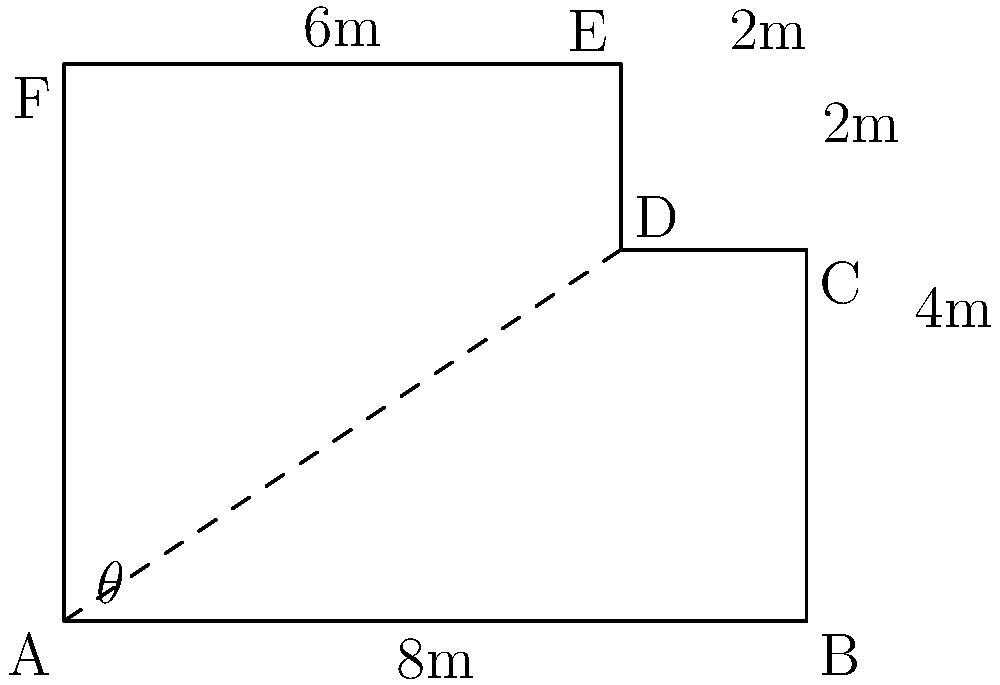An art gallery has an irregularly shaped floor plan as shown in the diagram. The gallery owner wants to calculate the total area to determine the cost of a new flooring installation. Given that angle $\theta = 33.69°$, calculate the total area of the art gallery floor in square meters. To find the total area, we'll divide the floor plan into rectangular and triangular sections:

1. Rectangle BCDE:
   Area = 8m × 4m = 32 m²

2. Rectangle ADEF:
   Area = 6m × 6m = 36 m²

3. Triangle ABD:
   We need to find the height (h) of this triangle.
   $\tan(\theta) = \frac{h}{8}$
   $h = 8 \tan(33.69°) = 5.33$ m
   Area = $\frac{1}{2} \times 8m \times 5.33m = 21.32$ m²

Total Area = Rectangle BCDE + Rectangle ADEF + Triangle ABD
           = 32 m² + 36 m² + 21.32 m²
           = 89.32 m²

Rounding to two decimal places: 89.32 m²
Answer: 89.32 m² 